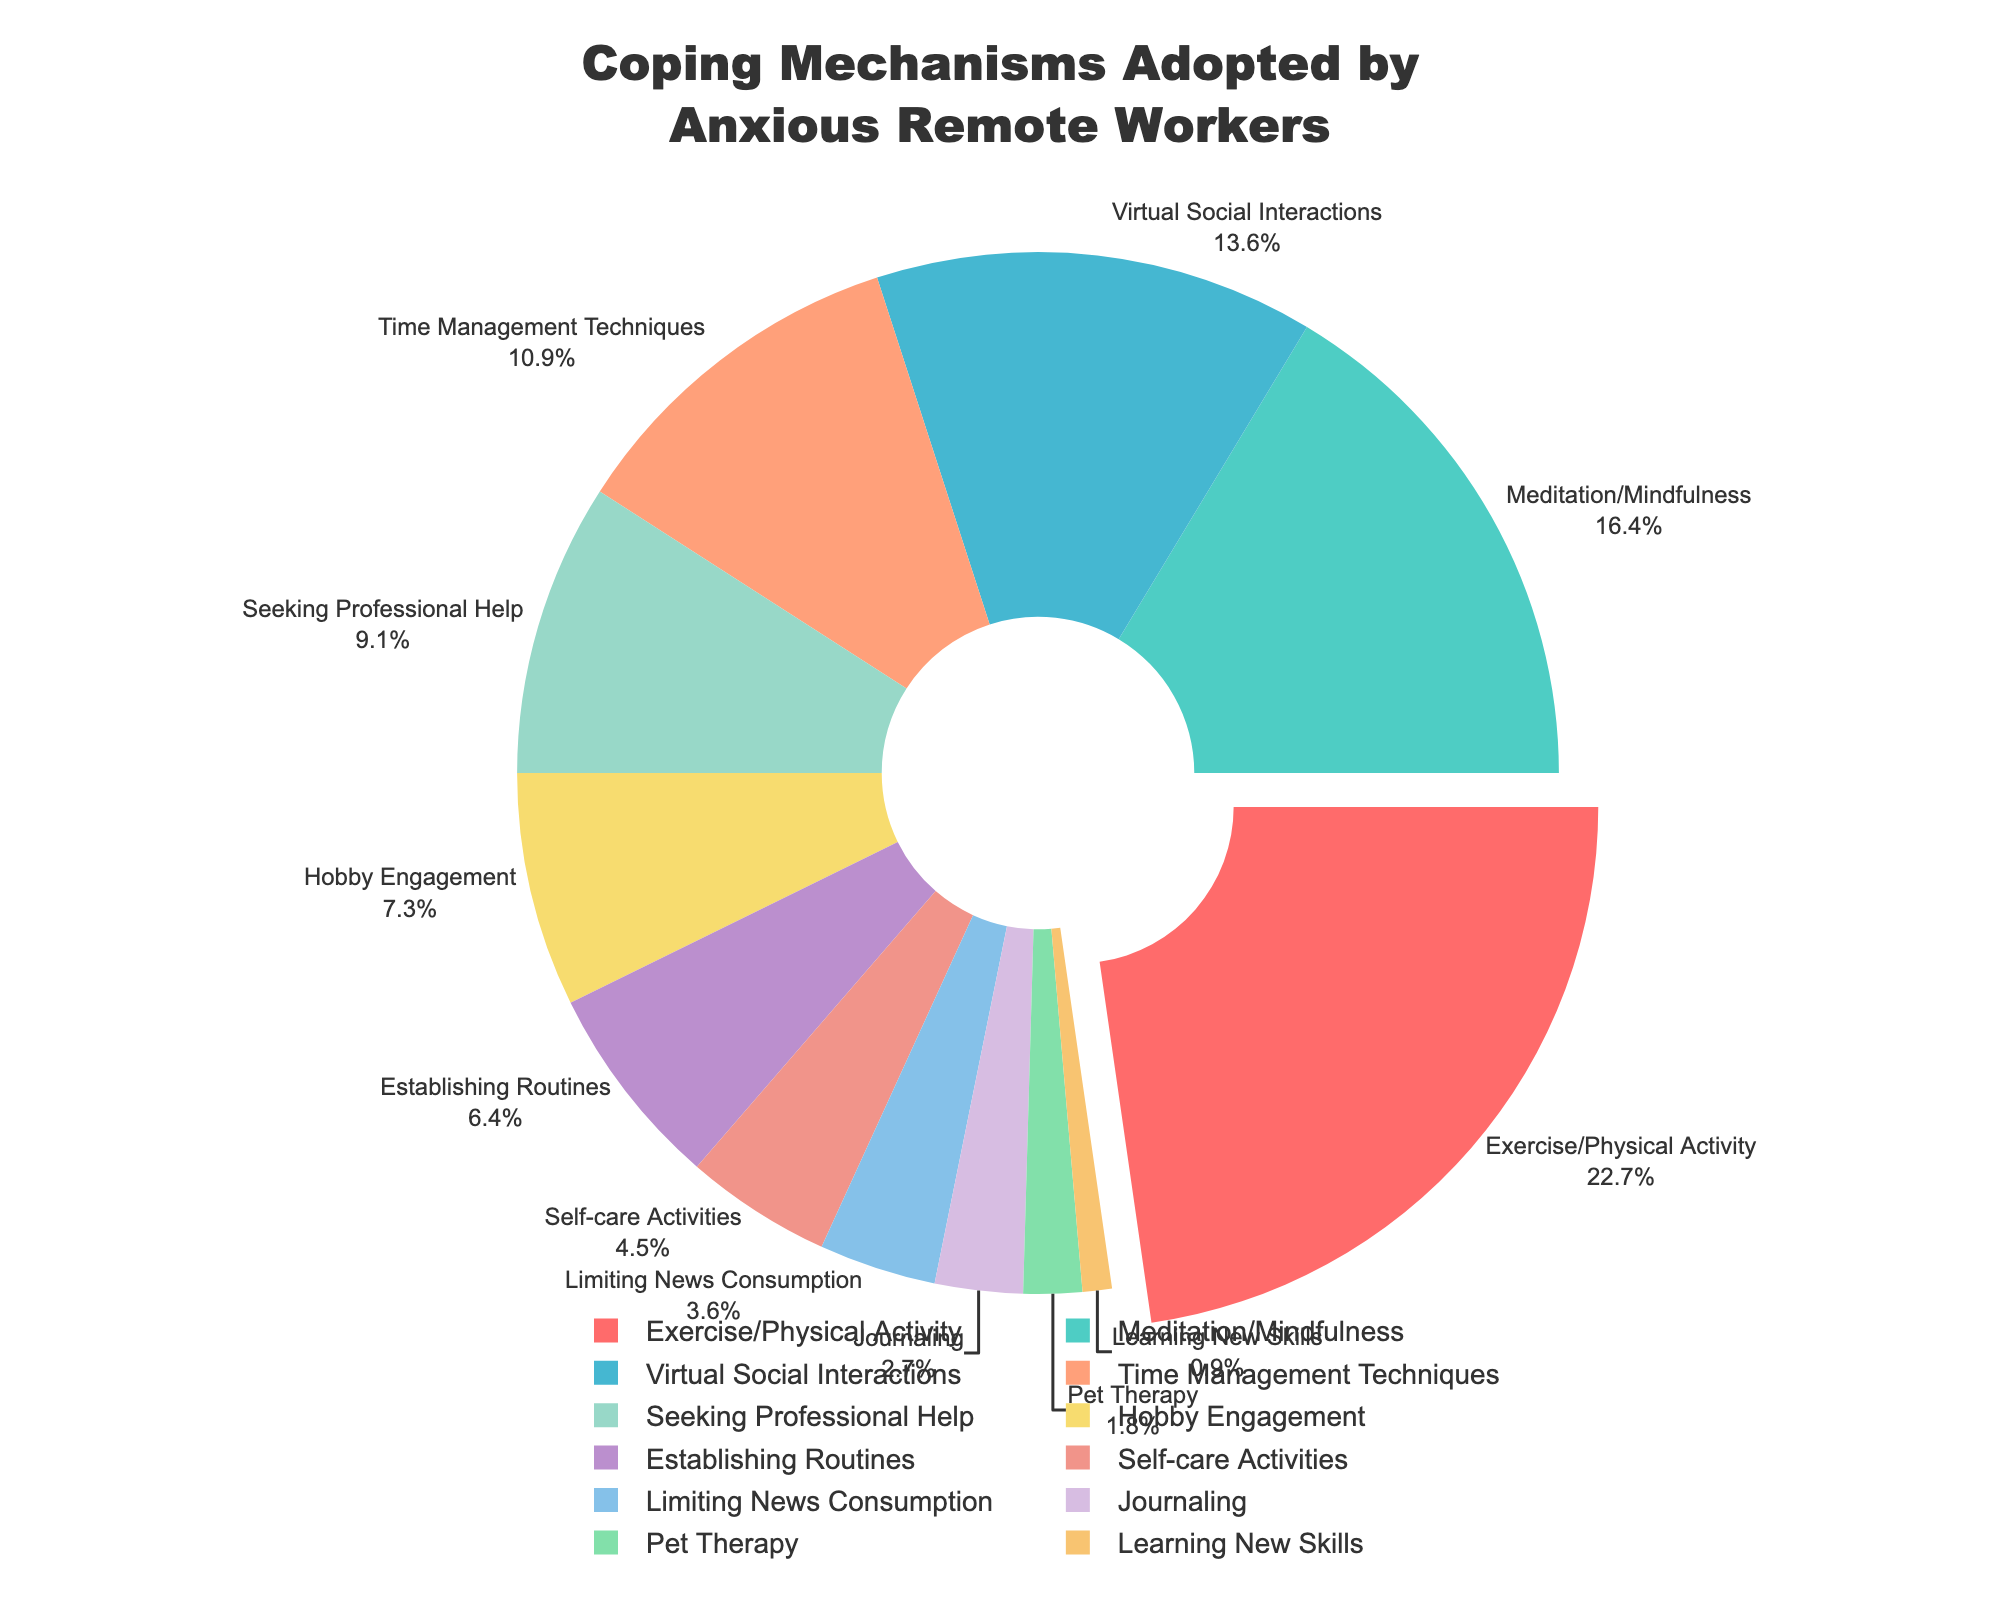What's the most common coping mechanism adopted by anxious remote workers? According to the pie chart, the largest section corresponds to Exercise/Physical Activity which makes up 25% of the total.
Answer: Exercise/Physical Activity Which coping mechanism is the least common? The smallest slice of the pie chart is Learning New Skills, which accounts for only 1% of the total.
Answer: Learning New Skills Compare the percentages of Meditation/Mindfulness and Virtual Social Interactions. Which one is higher and by how much? Meditation/Mindfulness accounts for 18% and Virtual Social Interactions account for 15%. The difference between them is 18% - 15% = 3%.
Answer: Meditation/Mindfulness by 3% What percentage of remote workers adopts either Time Management Techniques or Seeking Professional Help? Time Management Techniques make up 12% and Seeking Professional Help makes up 10%. The combined percentage is 12% + 10% = 22%.
Answer: 22% How does the percentage of Hobby Engagement compare to Establishing Routines? Hobby Engagement is 8% while Establishing Routines is 7%. Hobby Engagement is 1% higher than Establishing Routines.
Answer: Hobby Engagement by 1% Which coping mechanism appears in a green shade? The color code of the pie chart shows that Establishing Routines is in green, and it constitutes 7%.
Answer: Establishing Routines What is the combined percentage for Self-care Activities and Limiting News Consumption? Self-care Activities account for 5% and Limiting News Consumption accounts for 4%. Their combined total is 5% + 4% = 9%.
Answer: 9% Rank the top three coping mechanisms based on their adoption percentages. The top three sections are Exercise/Physical Activity (25%), Meditation/Mindfulness (18%), and Virtual Social Interactions (15%).
Answer: Exercise/Physical Activity, Meditation/Mindfulness, Virtual Social Interactions Which coping mechanism has the smallest difference from the median percentage value? To find the median, we must order the percentages: [1, 2, 3, 4, 5, 7, 8, 10, 12, 15, 18, 25]. The median of this array is the average of the 6th and 7th values (7% and 8%), so the median is (7+8)/2 = 7.5%. Hobby Engagement (8%) has the smallest difference from 7.5%, with a difference of 0.5%.
Answer: Hobby Engagement 